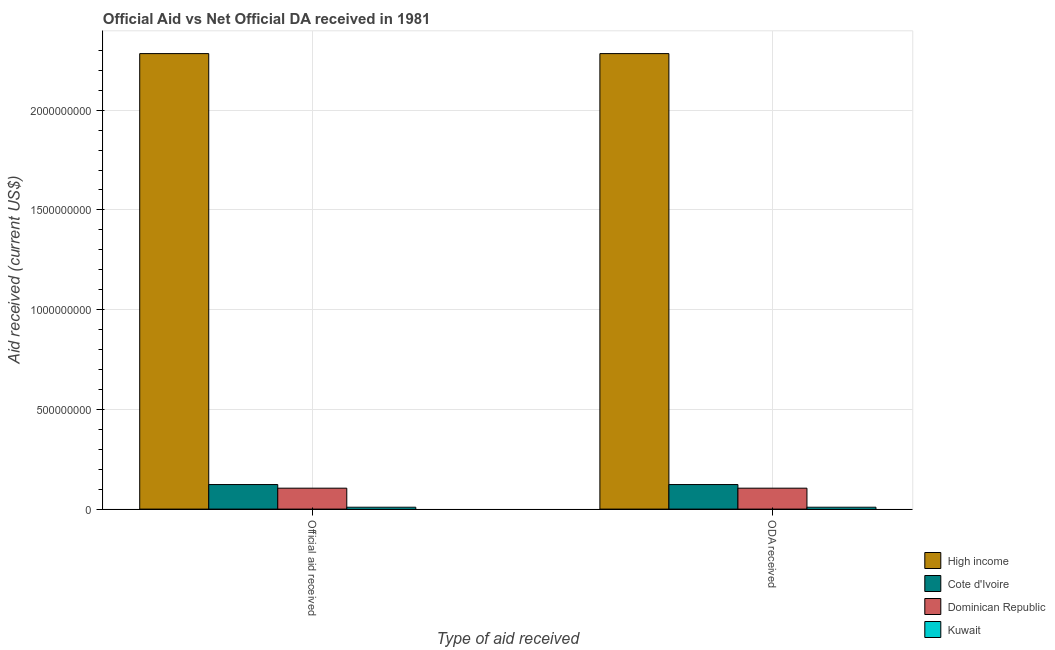How many groups of bars are there?
Offer a terse response. 2. Are the number of bars per tick equal to the number of legend labels?
Keep it short and to the point. Yes. How many bars are there on the 1st tick from the left?
Your answer should be very brief. 4. What is the label of the 2nd group of bars from the left?
Offer a terse response. ODA received. What is the oda received in Dominican Republic?
Provide a succinct answer. 1.05e+08. Across all countries, what is the maximum oda received?
Make the answer very short. 2.28e+09. Across all countries, what is the minimum oda received?
Provide a short and direct response. 9.40e+06. In which country was the official aid received maximum?
Provide a short and direct response. High income. In which country was the official aid received minimum?
Provide a short and direct response. Kuwait. What is the total oda received in the graph?
Provide a short and direct response. 2.52e+09. What is the difference between the official aid received in High income and that in Kuwait?
Provide a succinct answer. 2.27e+09. What is the difference between the official aid received in High income and the oda received in Kuwait?
Your answer should be very brief. 2.27e+09. What is the average oda received per country?
Ensure brevity in your answer.  6.30e+08. In how many countries, is the oda received greater than 1900000000 US$?
Offer a terse response. 1. What is the ratio of the oda received in Cote d'Ivoire to that in Kuwait?
Give a very brief answer. 13.09. In how many countries, is the official aid received greater than the average official aid received taken over all countries?
Make the answer very short. 1. What does the 4th bar from the left in ODA received represents?
Your answer should be very brief. Kuwait. What does the 1st bar from the right in Official aid received represents?
Your answer should be compact. Kuwait. Are all the bars in the graph horizontal?
Offer a terse response. No. What is the difference between two consecutive major ticks on the Y-axis?
Keep it short and to the point. 5.00e+08. Does the graph contain any zero values?
Offer a terse response. No. Does the graph contain grids?
Offer a very short reply. Yes. Where does the legend appear in the graph?
Provide a succinct answer. Bottom right. What is the title of the graph?
Keep it short and to the point. Official Aid vs Net Official DA received in 1981 . Does "Panama" appear as one of the legend labels in the graph?
Provide a succinct answer. No. What is the label or title of the X-axis?
Give a very brief answer. Type of aid received. What is the label or title of the Y-axis?
Make the answer very short. Aid received (current US$). What is the Aid received (current US$) of High income in Official aid received?
Offer a terse response. 2.28e+09. What is the Aid received (current US$) of Cote d'Ivoire in Official aid received?
Keep it short and to the point. 1.23e+08. What is the Aid received (current US$) of Dominican Republic in Official aid received?
Offer a terse response. 1.05e+08. What is the Aid received (current US$) in Kuwait in Official aid received?
Provide a succinct answer. 9.40e+06. What is the Aid received (current US$) of High income in ODA received?
Give a very brief answer. 2.28e+09. What is the Aid received (current US$) in Cote d'Ivoire in ODA received?
Offer a terse response. 1.23e+08. What is the Aid received (current US$) in Dominican Republic in ODA received?
Keep it short and to the point. 1.05e+08. What is the Aid received (current US$) in Kuwait in ODA received?
Ensure brevity in your answer.  9.40e+06. Across all Type of aid received, what is the maximum Aid received (current US$) in High income?
Your response must be concise. 2.28e+09. Across all Type of aid received, what is the maximum Aid received (current US$) of Cote d'Ivoire?
Your response must be concise. 1.23e+08. Across all Type of aid received, what is the maximum Aid received (current US$) in Dominican Republic?
Your answer should be compact. 1.05e+08. Across all Type of aid received, what is the maximum Aid received (current US$) in Kuwait?
Keep it short and to the point. 9.40e+06. Across all Type of aid received, what is the minimum Aid received (current US$) of High income?
Provide a short and direct response. 2.28e+09. Across all Type of aid received, what is the minimum Aid received (current US$) of Cote d'Ivoire?
Make the answer very short. 1.23e+08. Across all Type of aid received, what is the minimum Aid received (current US$) in Dominican Republic?
Your answer should be compact. 1.05e+08. Across all Type of aid received, what is the minimum Aid received (current US$) of Kuwait?
Your response must be concise. 9.40e+06. What is the total Aid received (current US$) in High income in the graph?
Offer a very short reply. 4.57e+09. What is the total Aid received (current US$) of Cote d'Ivoire in the graph?
Keep it short and to the point. 2.46e+08. What is the total Aid received (current US$) of Dominican Republic in the graph?
Ensure brevity in your answer.  2.10e+08. What is the total Aid received (current US$) of Kuwait in the graph?
Offer a terse response. 1.88e+07. What is the difference between the Aid received (current US$) in High income in Official aid received and that in ODA received?
Your answer should be compact. 0. What is the difference between the Aid received (current US$) of Cote d'Ivoire in Official aid received and that in ODA received?
Offer a very short reply. 0. What is the difference between the Aid received (current US$) of Dominican Republic in Official aid received and that in ODA received?
Your answer should be very brief. 0. What is the difference between the Aid received (current US$) in High income in Official aid received and the Aid received (current US$) in Cote d'Ivoire in ODA received?
Give a very brief answer. 2.16e+09. What is the difference between the Aid received (current US$) of High income in Official aid received and the Aid received (current US$) of Dominican Republic in ODA received?
Offer a very short reply. 2.18e+09. What is the difference between the Aid received (current US$) in High income in Official aid received and the Aid received (current US$) in Kuwait in ODA received?
Keep it short and to the point. 2.27e+09. What is the difference between the Aid received (current US$) of Cote d'Ivoire in Official aid received and the Aid received (current US$) of Dominican Republic in ODA received?
Provide a succinct answer. 1.81e+07. What is the difference between the Aid received (current US$) of Cote d'Ivoire in Official aid received and the Aid received (current US$) of Kuwait in ODA received?
Your answer should be very brief. 1.14e+08. What is the difference between the Aid received (current US$) of Dominican Republic in Official aid received and the Aid received (current US$) of Kuwait in ODA received?
Give a very brief answer. 9.55e+07. What is the average Aid received (current US$) of High income per Type of aid received?
Provide a succinct answer. 2.28e+09. What is the average Aid received (current US$) of Cote d'Ivoire per Type of aid received?
Your response must be concise. 1.23e+08. What is the average Aid received (current US$) of Dominican Republic per Type of aid received?
Keep it short and to the point. 1.05e+08. What is the average Aid received (current US$) in Kuwait per Type of aid received?
Your answer should be compact. 9.40e+06. What is the difference between the Aid received (current US$) in High income and Aid received (current US$) in Cote d'Ivoire in Official aid received?
Your answer should be compact. 2.16e+09. What is the difference between the Aid received (current US$) of High income and Aid received (current US$) of Dominican Republic in Official aid received?
Make the answer very short. 2.18e+09. What is the difference between the Aid received (current US$) of High income and Aid received (current US$) of Kuwait in Official aid received?
Provide a short and direct response. 2.27e+09. What is the difference between the Aid received (current US$) in Cote d'Ivoire and Aid received (current US$) in Dominican Republic in Official aid received?
Make the answer very short. 1.81e+07. What is the difference between the Aid received (current US$) in Cote d'Ivoire and Aid received (current US$) in Kuwait in Official aid received?
Provide a succinct answer. 1.14e+08. What is the difference between the Aid received (current US$) of Dominican Republic and Aid received (current US$) of Kuwait in Official aid received?
Your answer should be compact. 9.55e+07. What is the difference between the Aid received (current US$) of High income and Aid received (current US$) of Cote d'Ivoire in ODA received?
Your answer should be compact. 2.16e+09. What is the difference between the Aid received (current US$) in High income and Aid received (current US$) in Dominican Republic in ODA received?
Offer a very short reply. 2.18e+09. What is the difference between the Aid received (current US$) of High income and Aid received (current US$) of Kuwait in ODA received?
Provide a short and direct response. 2.27e+09. What is the difference between the Aid received (current US$) in Cote d'Ivoire and Aid received (current US$) in Dominican Republic in ODA received?
Your answer should be compact. 1.81e+07. What is the difference between the Aid received (current US$) in Cote d'Ivoire and Aid received (current US$) in Kuwait in ODA received?
Ensure brevity in your answer.  1.14e+08. What is the difference between the Aid received (current US$) of Dominican Republic and Aid received (current US$) of Kuwait in ODA received?
Make the answer very short. 9.55e+07. What is the ratio of the Aid received (current US$) of Cote d'Ivoire in Official aid received to that in ODA received?
Make the answer very short. 1. What is the ratio of the Aid received (current US$) in Dominican Republic in Official aid received to that in ODA received?
Ensure brevity in your answer.  1. What is the ratio of the Aid received (current US$) of Kuwait in Official aid received to that in ODA received?
Your answer should be compact. 1. What is the difference between the highest and the second highest Aid received (current US$) in Cote d'Ivoire?
Ensure brevity in your answer.  0. What is the difference between the highest and the lowest Aid received (current US$) of High income?
Offer a terse response. 0. What is the difference between the highest and the lowest Aid received (current US$) of Cote d'Ivoire?
Make the answer very short. 0. 